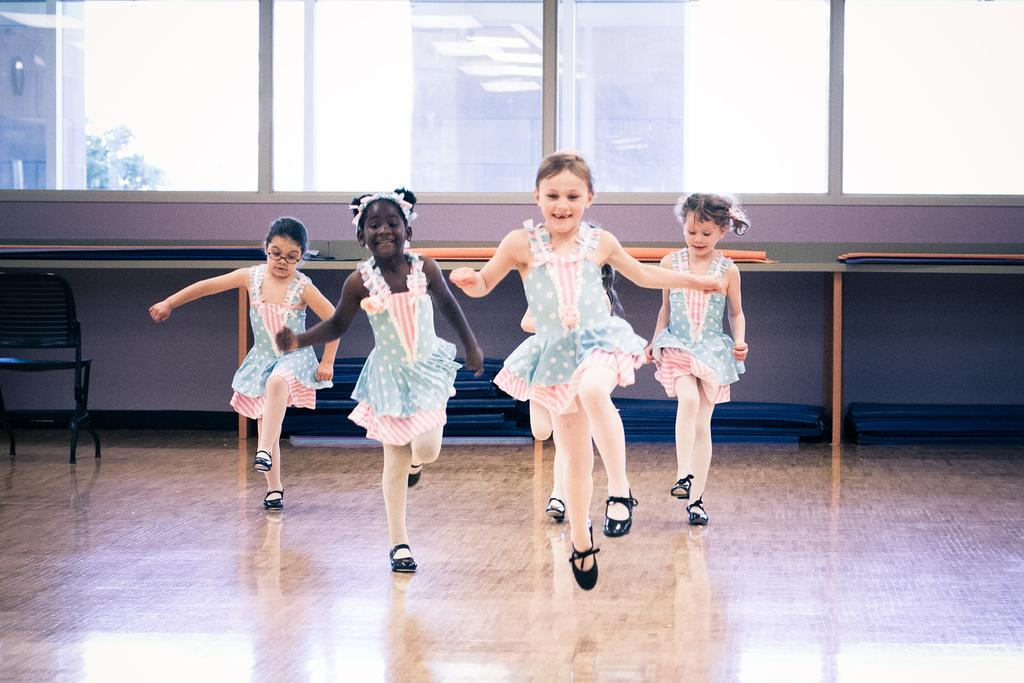How many girls are in the image? There are four girls in the image. What are the girls doing in the image? The girls are dancing on the floor. Where is the dancing happening in the image? The dancing is happening in the middle of the image. What can be seen on the left side of the image? There is a chair on the left side of the image. What is visible in the background of the image? There are glass windows in the background of the image. What type of suit is the girl in the middle wearing in the image? There is no suit visible in the image; the girls are wearing casual clothing while dancing. 